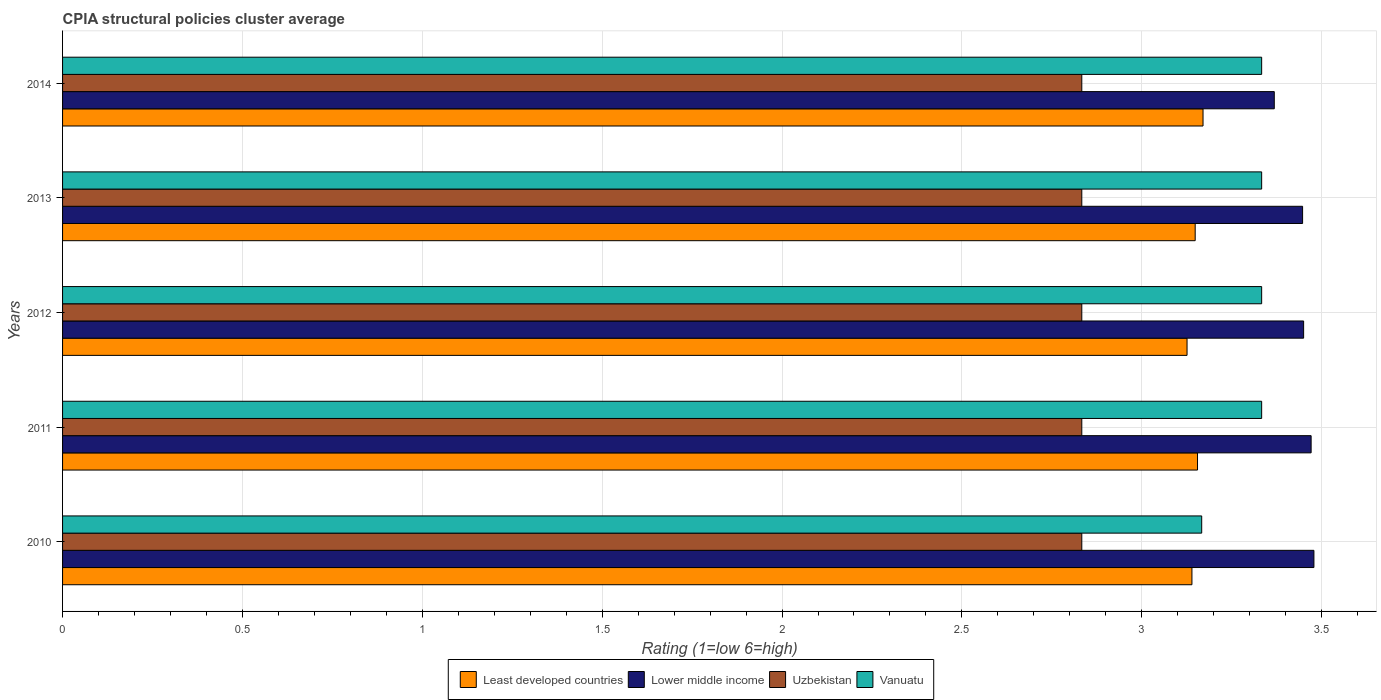Are the number of bars per tick equal to the number of legend labels?
Your answer should be very brief. Yes. Are the number of bars on each tick of the Y-axis equal?
Give a very brief answer. Yes. How many bars are there on the 3rd tick from the top?
Make the answer very short. 4. How many bars are there on the 5th tick from the bottom?
Provide a succinct answer. 4. What is the CPIA rating in Least developed countries in 2010?
Offer a terse response. 3.14. Across all years, what is the maximum CPIA rating in Uzbekistan?
Your answer should be compact. 2.83. Across all years, what is the minimum CPIA rating in Vanuatu?
Keep it short and to the point. 3.17. In which year was the CPIA rating in Least developed countries maximum?
Make the answer very short. 2014. In which year was the CPIA rating in Uzbekistan minimum?
Offer a very short reply. 2014. What is the total CPIA rating in Lower middle income in the graph?
Ensure brevity in your answer.  17.22. What is the difference between the CPIA rating in Lower middle income in 2010 and that in 2012?
Keep it short and to the point. 0.03. What is the difference between the CPIA rating in Lower middle income in 2013 and the CPIA rating in Least developed countries in 2012?
Ensure brevity in your answer.  0.32. What is the average CPIA rating in Uzbekistan per year?
Keep it short and to the point. 2.83. In how many years, is the CPIA rating in Least developed countries greater than 3.5 ?
Keep it short and to the point. 0. What is the difference between the highest and the second highest CPIA rating in Least developed countries?
Your answer should be very brief. 0.02. What is the difference between the highest and the lowest CPIA rating in Uzbekistan?
Provide a short and direct response. 3.333333329802457e-6. Is the sum of the CPIA rating in Uzbekistan in 2012 and 2014 greater than the maximum CPIA rating in Lower middle income across all years?
Offer a terse response. Yes. What does the 3rd bar from the top in 2012 represents?
Your answer should be compact. Lower middle income. What does the 2nd bar from the bottom in 2013 represents?
Your answer should be compact. Lower middle income. What is the difference between two consecutive major ticks on the X-axis?
Offer a terse response. 0.5. Does the graph contain any zero values?
Offer a very short reply. No. Does the graph contain grids?
Provide a short and direct response. Yes. Where does the legend appear in the graph?
Provide a short and direct response. Bottom center. What is the title of the graph?
Provide a short and direct response. CPIA structural policies cluster average. What is the label or title of the X-axis?
Make the answer very short. Rating (1=low 6=high). What is the label or title of the Y-axis?
Provide a short and direct response. Years. What is the Rating (1=low 6=high) of Least developed countries in 2010?
Your answer should be very brief. 3.14. What is the Rating (1=low 6=high) of Lower middle income in 2010?
Offer a very short reply. 3.48. What is the Rating (1=low 6=high) of Uzbekistan in 2010?
Provide a succinct answer. 2.83. What is the Rating (1=low 6=high) of Vanuatu in 2010?
Make the answer very short. 3.17. What is the Rating (1=low 6=high) of Least developed countries in 2011?
Your answer should be very brief. 3.16. What is the Rating (1=low 6=high) of Lower middle income in 2011?
Provide a short and direct response. 3.47. What is the Rating (1=low 6=high) in Uzbekistan in 2011?
Provide a succinct answer. 2.83. What is the Rating (1=low 6=high) in Vanuatu in 2011?
Give a very brief answer. 3.33. What is the Rating (1=low 6=high) in Least developed countries in 2012?
Provide a short and direct response. 3.13. What is the Rating (1=low 6=high) of Lower middle income in 2012?
Offer a very short reply. 3.45. What is the Rating (1=low 6=high) in Uzbekistan in 2012?
Your response must be concise. 2.83. What is the Rating (1=low 6=high) of Vanuatu in 2012?
Your response must be concise. 3.33. What is the Rating (1=low 6=high) of Least developed countries in 2013?
Your answer should be very brief. 3.15. What is the Rating (1=low 6=high) in Lower middle income in 2013?
Ensure brevity in your answer.  3.45. What is the Rating (1=low 6=high) of Uzbekistan in 2013?
Your answer should be very brief. 2.83. What is the Rating (1=low 6=high) of Vanuatu in 2013?
Keep it short and to the point. 3.33. What is the Rating (1=low 6=high) of Least developed countries in 2014?
Your answer should be compact. 3.17. What is the Rating (1=low 6=high) in Lower middle income in 2014?
Your answer should be compact. 3.37. What is the Rating (1=low 6=high) of Uzbekistan in 2014?
Your answer should be very brief. 2.83. What is the Rating (1=low 6=high) in Vanuatu in 2014?
Your answer should be very brief. 3.33. Across all years, what is the maximum Rating (1=low 6=high) of Least developed countries?
Offer a terse response. 3.17. Across all years, what is the maximum Rating (1=low 6=high) of Lower middle income?
Make the answer very short. 3.48. Across all years, what is the maximum Rating (1=low 6=high) in Uzbekistan?
Keep it short and to the point. 2.83. Across all years, what is the maximum Rating (1=low 6=high) of Vanuatu?
Make the answer very short. 3.33. Across all years, what is the minimum Rating (1=low 6=high) of Least developed countries?
Make the answer very short. 3.13. Across all years, what is the minimum Rating (1=low 6=high) in Lower middle income?
Make the answer very short. 3.37. Across all years, what is the minimum Rating (1=low 6=high) of Uzbekistan?
Ensure brevity in your answer.  2.83. Across all years, what is the minimum Rating (1=low 6=high) of Vanuatu?
Give a very brief answer. 3.17. What is the total Rating (1=low 6=high) in Least developed countries in the graph?
Give a very brief answer. 15.74. What is the total Rating (1=low 6=high) in Lower middle income in the graph?
Provide a short and direct response. 17.21. What is the total Rating (1=low 6=high) in Uzbekistan in the graph?
Keep it short and to the point. 14.17. What is the difference between the Rating (1=low 6=high) of Least developed countries in 2010 and that in 2011?
Your answer should be very brief. -0.02. What is the difference between the Rating (1=low 6=high) in Lower middle income in 2010 and that in 2011?
Offer a terse response. 0.01. What is the difference between the Rating (1=low 6=high) of Uzbekistan in 2010 and that in 2011?
Keep it short and to the point. 0. What is the difference between the Rating (1=low 6=high) of Vanuatu in 2010 and that in 2011?
Provide a short and direct response. -0.17. What is the difference between the Rating (1=low 6=high) of Least developed countries in 2010 and that in 2012?
Keep it short and to the point. 0.01. What is the difference between the Rating (1=low 6=high) in Lower middle income in 2010 and that in 2012?
Provide a short and direct response. 0.03. What is the difference between the Rating (1=low 6=high) of Least developed countries in 2010 and that in 2013?
Provide a short and direct response. -0.01. What is the difference between the Rating (1=low 6=high) in Lower middle income in 2010 and that in 2013?
Keep it short and to the point. 0.03. What is the difference between the Rating (1=low 6=high) of Uzbekistan in 2010 and that in 2013?
Keep it short and to the point. 0. What is the difference between the Rating (1=low 6=high) of Vanuatu in 2010 and that in 2013?
Your answer should be compact. -0.17. What is the difference between the Rating (1=low 6=high) of Least developed countries in 2010 and that in 2014?
Give a very brief answer. -0.03. What is the difference between the Rating (1=low 6=high) of Lower middle income in 2010 and that in 2014?
Give a very brief answer. 0.11. What is the difference between the Rating (1=low 6=high) of Vanuatu in 2010 and that in 2014?
Your response must be concise. -0.17. What is the difference between the Rating (1=low 6=high) in Least developed countries in 2011 and that in 2012?
Make the answer very short. 0.03. What is the difference between the Rating (1=low 6=high) of Lower middle income in 2011 and that in 2012?
Your answer should be compact. 0.02. What is the difference between the Rating (1=low 6=high) of Vanuatu in 2011 and that in 2012?
Ensure brevity in your answer.  0. What is the difference between the Rating (1=low 6=high) in Least developed countries in 2011 and that in 2013?
Keep it short and to the point. 0.01. What is the difference between the Rating (1=low 6=high) of Lower middle income in 2011 and that in 2013?
Offer a terse response. 0.02. What is the difference between the Rating (1=low 6=high) of Uzbekistan in 2011 and that in 2013?
Offer a terse response. 0. What is the difference between the Rating (1=low 6=high) of Least developed countries in 2011 and that in 2014?
Keep it short and to the point. -0.02. What is the difference between the Rating (1=low 6=high) of Lower middle income in 2011 and that in 2014?
Keep it short and to the point. 0.1. What is the difference between the Rating (1=low 6=high) in Uzbekistan in 2011 and that in 2014?
Give a very brief answer. 0. What is the difference between the Rating (1=low 6=high) in Vanuatu in 2011 and that in 2014?
Your answer should be compact. 0. What is the difference between the Rating (1=low 6=high) in Least developed countries in 2012 and that in 2013?
Make the answer very short. -0.02. What is the difference between the Rating (1=low 6=high) of Lower middle income in 2012 and that in 2013?
Your answer should be compact. 0. What is the difference between the Rating (1=low 6=high) of Least developed countries in 2012 and that in 2014?
Provide a succinct answer. -0.04. What is the difference between the Rating (1=low 6=high) in Lower middle income in 2012 and that in 2014?
Provide a succinct answer. 0.08. What is the difference between the Rating (1=low 6=high) of Uzbekistan in 2012 and that in 2014?
Your answer should be very brief. 0. What is the difference between the Rating (1=low 6=high) of Least developed countries in 2013 and that in 2014?
Provide a succinct answer. -0.02. What is the difference between the Rating (1=low 6=high) of Lower middle income in 2013 and that in 2014?
Keep it short and to the point. 0.08. What is the difference between the Rating (1=low 6=high) of Uzbekistan in 2013 and that in 2014?
Your answer should be compact. 0. What is the difference between the Rating (1=low 6=high) of Vanuatu in 2013 and that in 2014?
Make the answer very short. 0. What is the difference between the Rating (1=low 6=high) in Least developed countries in 2010 and the Rating (1=low 6=high) in Lower middle income in 2011?
Provide a succinct answer. -0.33. What is the difference between the Rating (1=low 6=high) of Least developed countries in 2010 and the Rating (1=low 6=high) of Uzbekistan in 2011?
Provide a succinct answer. 0.31. What is the difference between the Rating (1=low 6=high) of Least developed countries in 2010 and the Rating (1=low 6=high) of Vanuatu in 2011?
Offer a terse response. -0.19. What is the difference between the Rating (1=low 6=high) of Lower middle income in 2010 and the Rating (1=low 6=high) of Uzbekistan in 2011?
Your answer should be very brief. 0.65. What is the difference between the Rating (1=low 6=high) of Lower middle income in 2010 and the Rating (1=low 6=high) of Vanuatu in 2011?
Ensure brevity in your answer.  0.15. What is the difference between the Rating (1=low 6=high) in Uzbekistan in 2010 and the Rating (1=low 6=high) in Vanuatu in 2011?
Make the answer very short. -0.5. What is the difference between the Rating (1=low 6=high) in Least developed countries in 2010 and the Rating (1=low 6=high) in Lower middle income in 2012?
Your answer should be compact. -0.31. What is the difference between the Rating (1=low 6=high) of Least developed countries in 2010 and the Rating (1=low 6=high) of Uzbekistan in 2012?
Your response must be concise. 0.31. What is the difference between the Rating (1=low 6=high) in Least developed countries in 2010 and the Rating (1=low 6=high) in Vanuatu in 2012?
Provide a succinct answer. -0.19. What is the difference between the Rating (1=low 6=high) in Lower middle income in 2010 and the Rating (1=low 6=high) in Uzbekistan in 2012?
Your response must be concise. 0.65. What is the difference between the Rating (1=low 6=high) in Lower middle income in 2010 and the Rating (1=low 6=high) in Vanuatu in 2012?
Give a very brief answer. 0.15. What is the difference between the Rating (1=low 6=high) of Uzbekistan in 2010 and the Rating (1=low 6=high) of Vanuatu in 2012?
Offer a terse response. -0.5. What is the difference between the Rating (1=low 6=high) of Least developed countries in 2010 and the Rating (1=low 6=high) of Lower middle income in 2013?
Your answer should be very brief. -0.31. What is the difference between the Rating (1=low 6=high) of Least developed countries in 2010 and the Rating (1=low 6=high) of Uzbekistan in 2013?
Your answer should be very brief. 0.31. What is the difference between the Rating (1=low 6=high) in Least developed countries in 2010 and the Rating (1=low 6=high) in Vanuatu in 2013?
Keep it short and to the point. -0.19. What is the difference between the Rating (1=low 6=high) of Lower middle income in 2010 and the Rating (1=low 6=high) of Uzbekistan in 2013?
Make the answer very short. 0.65. What is the difference between the Rating (1=low 6=high) in Lower middle income in 2010 and the Rating (1=low 6=high) in Vanuatu in 2013?
Ensure brevity in your answer.  0.15. What is the difference between the Rating (1=low 6=high) in Least developed countries in 2010 and the Rating (1=low 6=high) in Lower middle income in 2014?
Offer a very short reply. -0.23. What is the difference between the Rating (1=low 6=high) of Least developed countries in 2010 and the Rating (1=low 6=high) of Uzbekistan in 2014?
Offer a terse response. 0.31. What is the difference between the Rating (1=low 6=high) of Least developed countries in 2010 and the Rating (1=low 6=high) of Vanuatu in 2014?
Make the answer very short. -0.19. What is the difference between the Rating (1=low 6=high) in Lower middle income in 2010 and the Rating (1=low 6=high) in Uzbekistan in 2014?
Keep it short and to the point. 0.65. What is the difference between the Rating (1=low 6=high) in Lower middle income in 2010 and the Rating (1=low 6=high) in Vanuatu in 2014?
Offer a very short reply. 0.15. What is the difference between the Rating (1=low 6=high) of Uzbekistan in 2010 and the Rating (1=low 6=high) of Vanuatu in 2014?
Your answer should be compact. -0.5. What is the difference between the Rating (1=low 6=high) in Least developed countries in 2011 and the Rating (1=low 6=high) in Lower middle income in 2012?
Make the answer very short. -0.29. What is the difference between the Rating (1=low 6=high) in Least developed countries in 2011 and the Rating (1=low 6=high) in Uzbekistan in 2012?
Give a very brief answer. 0.32. What is the difference between the Rating (1=low 6=high) in Least developed countries in 2011 and the Rating (1=low 6=high) in Vanuatu in 2012?
Offer a very short reply. -0.18. What is the difference between the Rating (1=low 6=high) in Lower middle income in 2011 and the Rating (1=low 6=high) in Uzbekistan in 2012?
Your answer should be compact. 0.64. What is the difference between the Rating (1=low 6=high) in Lower middle income in 2011 and the Rating (1=low 6=high) in Vanuatu in 2012?
Give a very brief answer. 0.14. What is the difference between the Rating (1=low 6=high) of Uzbekistan in 2011 and the Rating (1=low 6=high) of Vanuatu in 2012?
Your response must be concise. -0.5. What is the difference between the Rating (1=low 6=high) of Least developed countries in 2011 and the Rating (1=low 6=high) of Lower middle income in 2013?
Offer a very short reply. -0.29. What is the difference between the Rating (1=low 6=high) in Least developed countries in 2011 and the Rating (1=low 6=high) in Uzbekistan in 2013?
Provide a short and direct response. 0.32. What is the difference between the Rating (1=low 6=high) of Least developed countries in 2011 and the Rating (1=low 6=high) of Vanuatu in 2013?
Ensure brevity in your answer.  -0.18. What is the difference between the Rating (1=low 6=high) of Lower middle income in 2011 and the Rating (1=low 6=high) of Uzbekistan in 2013?
Keep it short and to the point. 0.64. What is the difference between the Rating (1=low 6=high) of Lower middle income in 2011 and the Rating (1=low 6=high) of Vanuatu in 2013?
Your answer should be compact. 0.14. What is the difference between the Rating (1=low 6=high) in Least developed countries in 2011 and the Rating (1=low 6=high) in Lower middle income in 2014?
Make the answer very short. -0.21. What is the difference between the Rating (1=low 6=high) in Least developed countries in 2011 and the Rating (1=low 6=high) in Uzbekistan in 2014?
Provide a short and direct response. 0.32. What is the difference between the Rating (1=low 6=high) of Least developed countries in 2011 and the Rating (1=low 6=high) of Vanuatu in 2014?
Ensure brevity in your answer.  -0.18. What is the difference between the Rating (1=low 6=high) in Lower middle income in 2011 and the Rating (1=low 6=high) in Uzbekistan in 2014?
Your answer should be very brief. 0.64. What is the difference between the Rating (1=low 6=high) in Lower middle income in 2011 and the Rating (1=low 6=high) in Vanuatu in 2014?
Make the answer very short. 0.14. What is the difference between the Rating (1=low 6=high) of Least developed countries in 2012 and the Rating (1=low 6=high) of Lower middle income in 2013?
Ensure brevity in your answer.  -0.32. What is the difference between the Rating (1=low 6=high) of Least developed countries in 2012 and the Rating (1=low 6=high) of Uzbekistan in 2013?
Offer a terse response. 0.29. What is the difference between the Rating (1=low 6=high) of Least developed countries in 2012 and the Rating (1=low 6=high) of Vanuatu in 2013?
Give a very brief answer. -0.21. What is the difference between the Rating (1=low 6=high) in Lower middle income in 2012 and the Rating (1=low 6=high) in Uzbekistan in 2013?
Offer a terse response. 0.62. What is the difference between the Rating (1=low 6=high) in Lower middle income in 2012 and the Rating (1=low 6=high) in Vanuatu in 2013?
Your answer should be very brief. 0.12. What is the difference between the Rating (1=low 6=high) in Uzbekistan in 2012 and the Rating (1=low 6=high) in Vanuatu in 2013?
Provide a succinct answer. -0.5. What is the difference between the Rating (1=low 6=high) in Least developed countries in 2012 and the Rating (1=low 6=high) in Lower middle income in 2014?
Provide a short and direct response. -0.24. What is the difference between the Rating (1=low 6=high) of Least developed countries in 2012 and the Rating (1=low 6=high) of Uzbekistan in 2014?
Provide a succinct answer. 0.29. What is the difference between the Rating (1=low 6=high) in Least developed countries in 2012 and the Rating (1=low 6=high) in Vanuatu in 2014?
Make the answer very short. -0.21. What is the difference between the Rating (1=low 6=high) of Lower middle income in 2012 and the Rating (1=low 6=high) of Uzbekistan in 2014?
Offer a very short reply. 0.62. What is the difference between the Rating (1=low 6=high) of Lower middle income in 2012 and the Rating (1=low 6=high) of Vanuatu in 2014?
Provide a short and direct response. 0.12. What is the difference between the Rating (1=low 6=high) in Least developed countries in 2013 and the Rating (1=low 6=high) in Lower middle income in 2014?
Provide a succinct answer. -0.22. What is the difference between the Rating (1=low 6=high) in Least developed countries in 2013 and the Rating (1=low 6=high) in Uzbekistan in 2014?
Make the answer very short. 0.32. What is the difference between the Rating (1=low 6=high) of Least developed countries in 2013 and the Rating (1=low 6=high) of Vanuatu in 2014?
Your response must be concise. -0.18. What is the difference between the Rating (1=low 6=high) of Lower middle income in 2013 and the Rating (1=low 6=high) of Uzbekistan in 2014?
Offer a terse response. 0.61. What is the difference between the Rating (1=low 6=high) in Lower middle income in 2013 and the Rating (1=low 6=high) in Vanuatu in 2014?
Keep it short and to the point. 0.11. What is the average Rating (1=low 6=high) of Least developed countries per year?
Your answer should be compact. 3.15. What is the average Rating (1=low 6=high) of Lower middle income per year?
Keep it short and to the point. 3.44. What is the average Rating (1=low 6=high) of Uzbekistan per year?
Your answer should be compact. 2.83. What is the average Rating (1=low 6=high) of Vanuatu per year?
Ensure brevity in your answer.  3.3. In the year 2010, what is the difference between the Rating (1=low 6=high) in Least developed countries and Rating (1=low 6=high) in Lower middle income?
Keep it short and to the point. -0.34. In the year 2010, what is the difference between the Rating (1=low 6=high) of Least developed countries and Rating (1=low 6=high) of Uzbekistan?
Your answer should be compact. 0.31. In the year 2010, what is the difference between the Rating (1=low 6=high) in Least developed countries and Rating (1=low 6=high) in Vanuatu?
Your response must be concise. -0.03. In the year 2010, what is the difference between the Rating (1=low 6=high) of Lower middle income and Rating (1=low 6=high) of Uzbekistan?
Ensure brevity in your answer.  0.65. In the year 2010, what is the difference between the Rating (1=low 6=high) in Lower middle income and Rating (1=low 6=high) in Vanuatu?
Offer a very short reply. 0.31. In the year 2010, what is the difference between the Rating (1=low 6=high) of Uzbekistan and Rating (1=low 6=high) of Vanuatu?
Your response must be concise. -0.33. In the year 2011, what is the difference between the Rating (1=low 6=high) in Least developed countries and Rating (1=low 6=high) in Lower middle income?
Offer a terse response. -0.32. In the year 2011, what is the difference between the Rating (1=low 6=high) of Least developed countries and Rating (1=low 6=high) of Uzbekistan?
Keep it short and to the point. 0.32. In the year 2011, what is the difference between the Rating (1=low 6=high) of Least developed countries and Rating (1=low 6=high) of Vanuatu?
Ensure brevity in your answer.  -0.18. In the year 2011, what is the difference between the Rating (1=low 6=high) of Lower middle income and Rating (1=low 6=high) of Uzbekistan?
Your answer should be very brief. 0.64. In the year 2011, what is the difference between the Rating (1=low 6=high) in Lower middle income and Rating (1=low 6=high) in Vanuatu?
Keep it short and to the point. 0.14. In the year 2011, what is the difference between the Rating (1=low 6=high) in Uzbekistan and Rating (1=low 6=high) in Vanuatu?
Provide a succinct answer. -0.5. In the year 2012, what is the difference between the Rating (1=low 6=high) of Least developed countries and Rating (1=low 6=high) of Lower middle income?
Make the answer very short. -0.32. In the year 2012, what is the difference between the Rating (1=low 6=high) in Least developed countries and Rating (1=low 6=high) in Uzbekistan?
Offer a terse response. 0.29. In the year 2012, what is the difference between the Rating (1=low 6=high) in Least developed countries and Rating (1=low 6=high) in Vanuatu?
Your response must be concise. -0.21. In the year 2012, what is the difference between the Rating (1=low 6=high) in Lower middle income and Rating (1=low 6=high) in Uzbekistan?
Give a very brief answer. 0.62. In the year 2012, what is the difference between the Rating (1=low 6=high) in Lower middle income and Rating (1=low 6=high) in Vanuatu?
Your answer should be compact. 0.12. In the year 2013, what is the difference between the Rating (1=low 6=high) of Least developed countries and Rating (1=low 6=high) of Lower middle income?
Your answer should be very brief. -0.3. In the year 2013, what is the difference between the Rating (1=low 6=high) of Least developed countries and Rating (1=low 6=high) of Uzbekistan?
Your response must be concise. 0.32. In the year 2013, what is the difference between the Rating (1=low 6=high) in Least developed countries and Rating (1=low 6=high) in Vanuatu?
Provide a succinct answer. -0.18. In the year 2013, what is the difference between the Rating (1=low 6=high) in Lower middle income and Rating (1=low 6=high) in Uzbekistan?
Offer a terse response. 0.61. In the year 2013, what is the difference between the Rating (1=low 6=high) in Lower middle income and Rating (1=low 6=high) in Vanuatu?
Keep it short and to the point. 0.11. In the year 2014, what is the difference between the Rating (1=low 6=high) in Least developed countries and Rating (1=low 6=high) in Lower middle income?
Offer a terse response. -0.2. In the year 2014, what is the difference between the Rating (1=low 6=high) of Least developed countries and Rating (1=low 6=high) of Uzbekistan?
Provide a short and direct response. 0.34. In the year 2014, what is the difference between the Rating (1=low 6=high) of Least developed countries and Rating (1=low 6=high) of Vanuatu?
Give a very brief answer. -0.16. In the year 2014, what is the difference between the Rating (1=low 6=high) in Lower middle income and Rating (1=low 6=high) in Uzbekistan?
Offer a terse response. 0.54. In the year 2014, what is the difference between the Rating (1=low 6=high) in Lower middle income and Rating (1=low 6=high) in Vanuatu?
Offer a very short reply. 0.04. In the year 2014, what is the difference between the Rating (1=low 6=high) in Uzbekistan and Rating (1=low 6=high) in Vanuatu?
Ensure brevity in your answer.  -0.5. What is the ratio of the Rating (1=low 6=high) in Lower middle income in 2010 to that in 2011?
Offer a terse response. 1. What is the ratio of the Rating (1=low 6=high) in Least developed countries in 2010 to that in 2012?
Offer a terse response. 1. What is the ratio of the Rating (1=low 6=high) of Lower middle income in 2010 to that in 2012?
Ensure brevity in your answer.  1.01. What is the ratio of the Rating (1=low 6=high) in Uzbekistan in 2010 to that in 2012?
Provide a succinct answer. 1. What is the ratio of the Rating (1=low 6=high) of Least developed countries in 2010 to that in 2013?
Make the answer very short. 1. What is the ratio of the Rating (1=low 6=high) of Lower middle income in 2010 to that in 2013?
Your response must be concise. 1.01. What is the ratio of the Rating (1=low 6=high) in Vanuatu in 2010 to that in 2013?
Your answer should be compact. 0.95. What is the ratio of the Rating (1=low 6=high) of Least developed countries in 2010 to that in 2014?
Offer a terse response. 0.99. What is the ratio of the Rating (1=low 6=high) in Lower middle income in 2010 to that in 2014?
Provide a succinct answer. 1.03. What is the ratio of the Rating (1=low 6=high) in Uzbekistan in 2010 to that in 2014?
Make the answer very short. 1. What is the ratio of the Rating (1=low 6=high) of Least developed countries in 2011 to that in 2012?
Ensure brevity in your answer.  1.01. What is the ratio of the Rating (1=low 6=high) in Lower middle income in 2011 to that in 2012?
Give a very brief answer. 1.01. What is the ratio of the Rating (1=low 6=high) in Uzbekistan in 2011 to that in 2012?
Your answer should be compact. 1. What is the ratio of the Rating (1=low 6=high) of Lower middle income in 2011 to that in 2013?
Ensure brevity in your answer.  1.01. What is the ratio of the Rating (1=low 6=high) of Uzbekistan in 2011 to that in 2013?
Keep it short and to the point. 1. What is the ratio of the Rating (1=low 6=high) of Lower middle income in 2011 to that in 2014?
Keep it short and to the point. 1.03. What is the ratio of the Rating (1=low 6=high) of Vanuatu in 2011 to that in 2014?
Your answer should be compact. 1. What is the ratio of the Rating (1=low 6=high) in Least developed countries in 2012 to that in 2013?
Your answer should be compact. 0.99. What is the ratio of the Rating (1=low 6=high) of Lower middle income in 2012 to that in 2013?
Your response must be concise. 1. What is the ratio of the Rating (1=low 6=high) of Uzbekistan in 2012 to that in 2013?
Make the answer very short. 1. What is the ratio of the Rating (1=low 6=high) of Vanuatu in 2012 to that in 2013?
Ensure brevity in your answer.  1. What is the ratio of the Rating (1=low 6=high) in Least developed countries in 2012 to that in 2014?
Your answer should be compact. 0.99. What is the ratio of the Rating (1=low 6=high) of Lower middle income in 2012 to that in 2014?
Ensure brevity in your answer.  1.02. What is the ratio of the Rating (1=low 6=high) of Uzbekistan in 2012 to that in 2014?
Your answer should be very brief. 1. What is the ratio of the Rating (1=low 6=high) in Vanuatu in 2012 to that in 2014?
Ensure brevity in your answer.  1. What is the ratio of the Rating (1=low 6=high) of Least developed countries in 2013 to that in 2014?
Provide a succinct answer. 0.99. What is the ratio of the Rating (1=low 6=high) of Lower middle income in 2013 to that in 2014?
Your answer should be very brief. 1.02. What is the difference between the highest and the second highest Rating (1=low 6=high) of Least developed countries?
Make the answer very short. 0.02. What is the difference between the highest and the second highest Rating (1=low 6=high) in Lower middle income?
Provide a succinct answer. 0.01. What is the difference between the highest and the second highest Rating (1=low 6=high) in Vanuatu?
Your answer should be very brief. 0. What is the difference between the highest and the lowest Rating (1=low 6=high) of Least developed countries?
Your answer should be compact. 0.04. What is the difference between the highest and the lowest Rating (1=low 6=high) in Lower middle income?
Offer a terse response. 0.11. 